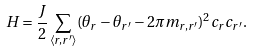Convert formula to latex. <formula><loc_0><loc_0><loc_500><loc_500>H = \frac { J } { 2 } \sum _ { \left < { r , r ^ { \prime } } \right > } ( \theta _ { r } - \theta _ { r ^ { \prime } } - 2 \pi m _ { r , r ^ { \prime } } ) ^ { 2 } c _ { r } c _ { r ^ { \prime } } .</formula> 